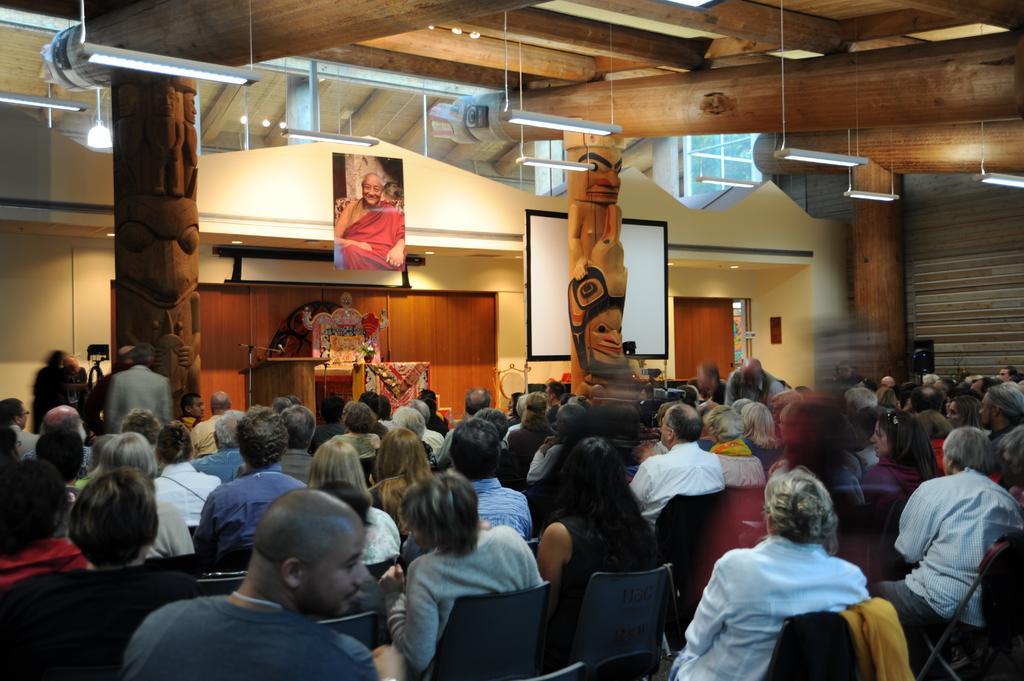In one or two sentences, can you explain what this image depicts? Here in this picture in the front we can see number of people sitting on chairs that are present on the floor and in front of them we can see a speech desk with microphone present on it and beside that we can see some other things also present and above that we can see a portrait of a person hanging on the roof and we can also see number of lights present on the roof and on the left side we can see people standing and we can see the pillar of the building are carved and we can also see a projector screen present and beside that we can see a door present. 